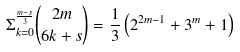Convert formula to latex. <formula><loc_0><loc_0><loc_500><loc_500>\Sigma ^ { \frac { m - s } { 3 } } _ { k = 0 } \binom { 2 m } { 6 k + s } = \frac { 1 } { 3 } \left ( 2 ^ { 2 m - 1 } + 3 ^ { m } + 1 \right )</formula> 